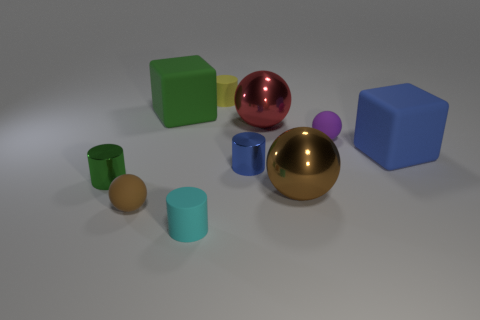Subtract all cyan cylinders. How many brown balls are left? 2 Subtract all small cyan matte cylinders. How many cylinders are left? 3 Subtract all yellow cylinders. How many cylinders are left? 3 Subtract all cylinders. How many objects are left? 6 Subtract all purple cylinders. Subtract all red balls. How many cylinders are left? 4 Subtract all cyan rubber objects. Subtract all tiny yellow rubber cylinders. How many objects are left? 8 Add 6 big metallic things. How many big metallic things are left? 8 Add 1 tiny purple metal balls. How many tiny purple metal balls exist? 1 Subtract 0 yellow blocks. How many objects are left? 10 